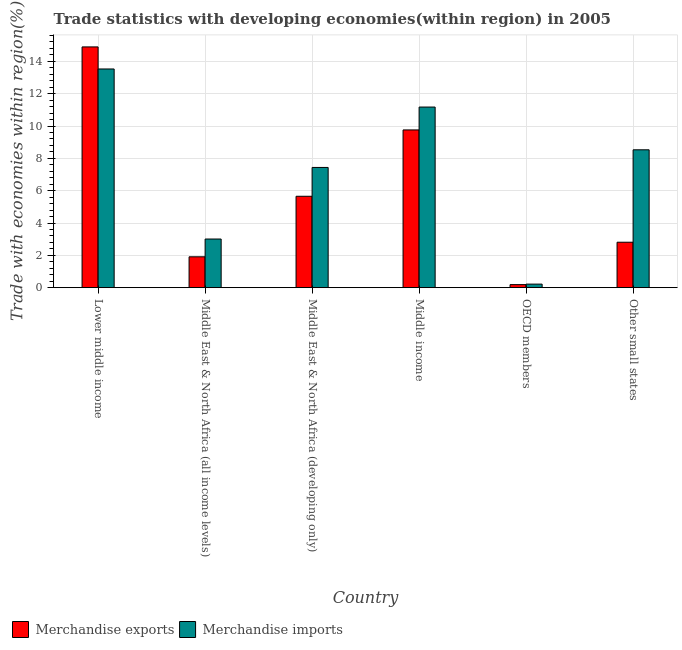How many bars are there on the 6th tick from the left?
Your answer should be compact. 2. How many bars are there on the 2nd tick from the right?
Ensure brevity in your answer.  2. What is the label of the 2nd group of bars from the left?
Make the answer very short. Middle East & North Africa (all income levels). In how many cases, is the number of bars for a given country not equal to the number of legend labels?
Offer a terse response. 0. What is the merchandise exports in Other small states?
Your answer should be compact. 2.81. Across all countries, what is the maximum merchandise exports?
Offer a terse response. 14.89. Across all countries, what is the minimum merchandise exports?
Provide a succinct answer. 0.19. In which country was the merchandise exports maximum?
Keep it short and to the point. Lower middle income. What is the total merchandise exports in the graph?
Keep it short and to the point. 35.21. What is the difference between the merchandise exports in Middle East & North Africa (developing only) and that in Other small states?
Ensure brevity in your answer.  2.84. What is the difference between the merchandise imports in OECD members and the merchandise exports in Middle income?
Your answer should be compact. -9.54. What is the average merchandise imports per country?
Ensure brevity in your answer.  7.32. What is the difference between the merchandise imports and merchandise exports in OECD members?
Give a very brief answer. 0.03. In how many countries, is the merchandise imports greater than 4.4 %?
Provide a succinct answer. 4. What is the ratio of the merchandise exports in Middle East & North Africa (developing only) to that in Middle income?
Offer a terse response. 0.58. What is the difference between the highest and the second highest merchandise imports?
Give a very brief answer. 2.36. What is the difference between the highest and the lowest merchandise exports?
Make the answer very short. 14.71. In how many countries, is the merchandise exports greater than the average merchandise exports taken over all countries?
Offer a terse response. 2. Is the sum of the merchandise imports in Middle income and Other small states greater than the maximum merchandise exports across all countries?
Ensure brevity in your answer.  Yes. What does the 2nd bar from the left in Other small states represents?
Your response must be concise. Merchandise imports. What does the 2nd bar from the right in Middle income represents?
Provide a succinct answer. Merchandise exports. How many bars are there?
Make the answer very short. 12. Does the graph contain any zero values?
Your response must be concise. No. How many legend labels are there?
Ensure brevity in your answer.  2. How are the legend labels stacked?
Your answer should be very brief. Horizontal. What is the title of the graph?
Provide a short and direct response. Trade statistics with developing economies(within region) in 2005. Does "ODA received" appear as one of the legend labels in the graph?
Offer a very short reply. No. What is the label or title of the Y-axis?
Keep it short and to the point. Trade with economies within region(%). What is the Trade with economies within region(%) in Merchandise exports in Lower middle income?
Your response must be concise. 14.89. What is the Trade with economies within region(%) of Merchandise imports in Lower middle income?
Give a very brief answer. 13.53. What is the Trade with economies within region(%) of Merchandise exports in Middle East & North Africa (all income levels)?
Offer a terse response. 1.91. What is the Trade with economies within region(%) of Merchandise imports in Middle East & North Africa (all income levels)?
Your answer should be compact. 3.01. What is the Trade with economies within region(%) of Merchandise exports in Middle East & North Africa (developing only)?
Provide a short and direct response. 5.65. What is the Trade with economies within region(%) in Merchandise imports in Middle East & North Africa (developing only)?
Provide a succinct answer. 7.44. What is the Trade with economies within region(%) of Merchandise exports in Middle income?
Make the answer very short. 9.76. What is the Trade with economies within region(%) in Merchandise imports in Middle income?
Your answer should be compact. 11.17. What is the Trade with economies within region(%) in Merchandise exports in OECD members?
Keep it short and to the point. 0.19. What is the Trade with economies within region(%) of Merchandise imports in OECD members?
Your answer should be very brief. 0.22. What is the Trade with economies within region(%) of Merchandise exports in Other small states?
Your answer should be compact. 2.81. What is the Trade with economies within region(%) of Merchandise imports in Other small states?
Your response must be concise. 8.53. Across all countries, what is the maximum Trade with economies within region(%) in Merchandise exports?
Make the answer very short. 14.89. Across all countries, what is the maximum Trade with economies within region(%) in Merchandise imports?
Give a very brief answer. 13.53. Across all countries, what is the minimum Trade with economies within region(%) of Merchandise exports?
Provide a short and direct response. 0.19. Across all countries, what is the minimum Trade with economies within region(%) of Merchandise imports?
Provide a short and direct response. 0.22. What is the total Trade with economies within region(%) of Merchandise exports in the graph?
Ensure brevity in your answer.  35.21. What is the total Trade with economies within region(%) in Merchandise imports in the graph?
Offer a very short reply. 43.9. What is the difference between the Trade with economies within region(%) in Merchandise exports in Lower middle income and that in Middle East & North Africa (all income levels)?
Offer a very short reply. 12.99. What is the difference between the Trade with economies within region(%) of Merchandise imports in Lower middle income and that in Middle East & North Africa (all income levels)?
Offer a very short reply. 10.52. What is the difference between the Trade with economies within region(%) in Merchandise exports in Lower middle income and that in Middle East & North Africa (developing only)?
Make the answer very short. 9.24. What is the difference between the Trade with economies within region(%) of Merchandise imports in Lower middle income and that in Middle East & North Africa (developing only)?
Provide a succinct answer. 6.09. What is the difference between the Trade with economies within region(%) in Merchandise exports in Lower middle income and that in Middle income?
Give a very brief answer. 5.14. What is the difference between the Trade with economies within region(%) in Merchandise imports in Lower middle income and that in Middle income?
Make the answer very short. 2.36. What is the difference between the Trade with economies within region(%) of Merchandise exports in Lower middle income and that in OECD members?
Offer a terse response. 14.71. What is the difference between the Trade with economies within region(%) of Merchandise imports in Lower middle income and that in OECD members?
Ensure brevity in your answer.  13.31. What is the difference between the Trade with economies within region(%) of Merchandise exports in Lower middle income and that in Other small states?
Make the answer very short. 12.08. What is the difference between the Trade with economies within region(%) in Merchandise imports in Lower middle income and that in Other small states?
Provide a succinct answer. 5. What is the difference between the Trade with economies within region(%) of Merchandise exports in Middle East & North Africa (all income levels) and that in Middle East & North Africa (developing only)?
Provide a short and direct response. -3.75. What is the difference between the Trade with economies within region(%) of Merchandise imports in Middle East & North Africa (all income levels) and that in Middle East & North Africa (developing only)?
Your answer should be very brief. -4.43. What is the difference between the Trade with economies within region(%) of Merchandise exports in Middle East & North Africa (all income levels) and that in Middle income?
Make the answer very short. -7.85. What is the difference between the Trade with economies within region(%) of Merchandise imports in Middle East & North Africa (all income levels) and that in Middle income?
Offer a very short reply. -8.16. What is the difference between the Trade with economies within region(%) of Merchandise exports in Middle East & North Africa (all income levels) and that in OECD members?
Ensure brevity in your answer.  1.72. What is the difference between the Trade with economies within region(%) of Merchandise imports in Middle East & North Africa (all income levels) and that in OECD members?
Make the answer very short. 2.79. What is the difference between the Trade with economies within region(%) in Merchandise exports in Middle East & North Africa (all income levels) and that in Other small states?
Offer a terse response. -0.9. What is the difference between the Trade with economies within region(%) in Merchandise imports in Middle East & North Africa (all income levels) and that in Other small states?
Your answer should be compact. -5.52. What is the difference between the Trade with economies within region(%) in Merchandise exports in Middle East & North Africa (developing only) and that in Middle income?
Your answer should be very brief. -4.1. What is the difference between the Trade with economies within region(%) in Merchandise imports in Middle East & North Africa (developing only) and that in Middle income?
Offer a very short reply. -3.74. What is the difference between the Trade with economies within region(%) in Merchandise exports in Middle East & North Africa (developing only) and that in OECD members?
Your response must be concise. 5.47. What is the difference between the Trade with economies within region(%) of Merchandise imports in Middle East & North Africa (developing only) and that in OECD members?
Your response must be concise. 7.22. What is the difference between the Trade with economies within region(%) of Merchandise exports in Middle East & North Africa (developing only) and that in Other small states?
Your answer should be compact. 2.84. What is the difference between the Trade with economies within region(%) in Merchandise imports in Middle East & North Africa (developing only) and that in Other small states?
Make the answer very short. -1.09. What is the difference between the Trade with economies within region(%) of Merchandise exports in Middle income and that in OECD members?
Your answer should be very brief. 9.57. What is the difference between the Trade with economies within region(%) in Merchandise imports in Middle income and that in OECD members?
Your answer should be compact. 10.95. What is the difference between the Trade with economies within region(%) of Merchandise exports in Middle income and that in Other small states?
Your answer should be compact. 6.95. What is the difference between the Trade with economies within region(%) in Merchandise imports in Middle income and that in Other small states?
Ensure brevity in your answer.  2.64. What is the difference between the Trade with economies within region(%) of Merchandise exports in OECD members and that in Other small states?
Keep it short and to the point. -2.62. What is the difference between the Trade with economies within region(%) of Merchandise imports in OECD members and that in Other small states?
Provide a short and direct response. -8.31. What is the difference between the Trade with economies within region(%) in Merchandise exports in Lower middle income and the Trade with economies within region(%) in Merchandise imports in Middle East & North Africa (all income levels)?
Your answer should be compact. 11.88. What is the difference between the Trade with economies within region(%) of Merchandise exports in Lower middle income and the Trade with economies within region(%) of Merchandise imports in Middle East & North Africa (developing only)?
Your answer should be very brief. 7.46. What is the difference between the Trade with economies within region(%) in Merchandise exports in Lower middle income and the Trade with economies within region(%) in Merchandise imports in Middle income?
Offer a very short reply. 3.72. What is the difference between the Trade with economies within region(%) of Merchandise exports in Lower middle income and the Trade with economies within region(%) of Merchandise imports in OECD members?
Offer a terse response. 14.68. What is the difference between the Trade with economies within region(%) of Merchandise exports in Lower middle income and the Trade with economies within region(%) of Merchandise imports in Other small states?
Give a very brief answer. 6.37. What is the difference between the Trade with economies within region(%) of Merchandise exports in Middle East & North Africa (all income levels) and the Trade with economies within region(%) of Merchandise imports in Middle East & North Africa (developing only)?
Your answer should be compact. -5.53. What is the difference between the Trade with economies within region(%) in Merchandise exports in Middle East & North Africa (all income levels) and the Trade with economies within region(%) in Merchandise imports in Middle income?
Ensure brevity in your answer.  -9.26. What is the difference between the Trade with economies within region(%) of Merchandise exports in Middle East & North Africa (all income levels) and the Trade with economies within region(%) of Merchandise imports in OECD members?
Make the answer very short. 1.69. What is the difference between the Trade with economies within region(%) in Merchandise exports in Middle East & North Africa (all income levels) and the Trade with economies within region(%) in Merchandise imports in Other small states?
Your answer should be compact. -6.62. What is the difference between the Trade with economies within region(%) of Merchandise exports in Middle East & North Africa (developing only) and the Trade with economies within region(%) of Merchandise imports in Middle income?
Your answer should be compact. -5.52. What is the difference between the Trade with economies within region(%) of Merchandise exports in Middle East & North Africa (developing only) and the Trade with economies within region(%) of Merchandise imports in OECD members?
Provide a succinct answer. 5.43. What is the difference between the Trade with economies within region(%) of Merchandise exports in Middle East & North Africa (developing only) and the Trade with economies within region(%) of Merchandise imports in Other small states?
Give a very brief answer. -2.87. What is the difference between the Trade with economies within region(%) in Merchandise exports in Middle income and the Trade with economies within region(%) in Merchandise imports in OECD members?
Ensure brevity in your answer.  9.54. What is the difference between the Trade with economies within region(%) of Merchandise exports in Middle income and the Trade with economies within region(%) of Merchandise imports in Other small states?
Make the answer very short. 1.23. What is the difference between the Trade with economies within region(%) of Merchandise exports in OECD members and the Trade with economies within region(%) of Merchandise imports in Other small states?
Offer a terse response. -8.34. What is the average Trade with economies within region(%) of Merchandise exports per country?
Provide a succinct answer. 5.87. What is the average Trade with economies within region(%) in Merchandise imports per country?
Provide a succinct answer. 7.32. What is the difference between the Trade with economies within region(%) in Merchandise exports and Trade with economies within region(%) in Merchandise imports in Lower middle income?
Your answer should be compact. 1.37. What is the difference between the Trade with economies within region(%) of Merchandise exports and Trade with economies within region(%) of Merchandise imports in Middle East & North Africa (all income levels)?
Give a very brief answer. -1.1. What is the difference between the Trade with economies within region(%) of Merchandise exports and Trade with economies within region(%) of Merchandise imports in Middle East & North Africa (developing only)?
Offer a very short reply. -1.78. What is the difference between the Trade with economies within region(%) of Merchandise exports and Trade with economies within region(%) of Merchandise imports in Middle income?
Provide a succinct answer. -1.41. What is the difference between the Trade with economies within region(%) in Merchandise exports and Trade with economies within region(%) in Merchandise imports in OECD members?
Your answer should be compact. -0.03. What is the difference between the Trade with economies within region(%) in Merchandise exports and Trade with economies within region(%) in Merchandise imports in Other small states?
Provide a short and direct response. -5.72. What is the ratio of the Trade with economies within region(%) in Merchandise exports in Lower middle income to that in Middle East & North Africa (all income levels)?
Your answer should be very brief. 7.8. What is the ratio of the Trade with economies within region(%) in Merchandise imports in Lower middle income to that in Middle East & North Africa (all income levels)?
Provide a short and direct response. 4.5. What is the ratio of the Trade with economies within region(%) of Merchandise exports in Lower middle income to that in Middle East & North Africa (developing only)?
Ensure brevity in your answer.  2.63. What is the ratio of the Trade with economies within region(%) in Merchandise imports in Lower middle income to that in Middle East & North Africa (developing only)?
Make the answer very short. 1.82. What is the ratio of the Trade with economies within region(%) of Merchandise exports in Lower middle income to that in Middle income?
Give a very brief answer. 1.53. What is the ratio of the Trade with economies within region(%) in Merchandise imports in Lower middle income to that in Middle income?
Your answer should be compact. 1.21. What is the ratio of the Trade with economies within region(%) in Merchandise exports in Lower middle income to that in OECD members?
Provide a short and direct response. 79.11. What is the ratio of the Trade with economies within region(%) in Merchandise imports in Lower middle income to that in OECD members?
Ensure brevity in your answer.  61.79. What is the ratio of the Trade with economies within region(%) of Merchandise exports in Lower middle income to that in Other small states?
Keep it short and to the point. 5.3. What is the ratio of the Trade with economies within region(%) of Merchandise imports in Lower middle income to that in Other small states?
Provide a succinct answer. 1.59. What is the ratio of the Trade with economies within region(%) in Merchandise exports in Middle East & North Africa (all income levels) to that in Middle East & North Africa (developing only)?
Make the answer very short. 0.34. What is the ratio of the Trade with economies within region(%) in Merchandise imports in Middle East & North Africa (all income levels) to that in Middle East & North Africa (developing only)?
Your answer should be very brief. 0.4. What is the ratio of the Trade with economies within region(%) in Merchandise exports in Middle East & North Africa (all income levels) to that in Middle income?
Keep it short and to the point. 0.2. What is the ratio of the Trade with economies within region(%) of Merchandise imports in Middle East & North Africa (all income levels) to that in Middle income?
Ensure brevity in your answer.  0.27. What is the ratio of the Trade with economies within region(%) in Merchandise exports in Middle East & North Africa (all income levels) to that in OECD members?
Make the answer very short. 10.14. What is the ratio of the Trade with economies within region(%) of Merchandise imports in Middle East & North Africa (all income levels) to that in OECD members?
Give a very brief answer. 13.74. What is the ratio of the Trade with economies within region(%) in Merchandise exports in Middle East & North Africa (all income levels) to that in Other small states?
Offer a very short reply. 0.68. What is the ratio of the Trade with economies within region(%) in Merchandise imports in Middle East & North Africa (all income levels) to that in Other small states?
Provide a succinct answer. 0.35. What is the ratio of the Trade with economies within region(%) of Merchandise exports in Middle East & North Africa (developing only) to that in Middle income?
Give a very brief answer. 0.58. What is the ratio of the Trade with economies within region(%) in Merchandise imports in Middle East & North Africa (developing only) to that in Middle income?
Provide a short and direct response. 0.67. What is the ratio of the Trade with economies within region(%) in Merchandise exports in Middle East & North Africa (developing only) to that in OECD members?
Offer a terse response. 30.03. What is the ratio of the Trade with economies within region(%) of Merchandise imports in Middle East & North Africa (developing only) to that in OECD members?
Provide a short and direct response. 33.97. What is the ratio of the Trade with economies within region(%) of Merchandise exports in Middle East & North Africa (developing only) to that in Other small states?
Provide a short and direct response. 2.01. What is the ratio of the Trade with economies within region(%) in Merchandise imports in Middle East & North Africa (developing only) to that in Other small states?
Give a very brief answer. 0.87. What is the ratio of the Trade with economies within region(%) of Merchandise exports in Middle income to that in OECD members?
Keep it short and to the point. 51.84. What is the ratio of the Trade with economies within region(%) of Merchandise imports in Middle income to that in OECD members?
Your answer should be compact. 51.03. What is the ratio of the Trade with economies within region(%) of Merchandise exports in Middle income to that in Other small states?
Offer a very short reply. 3.47. What is the ratio of the Trade with economies within region(%) of Merchandise imports in Middle income to that in Other small states?
Ensure brevity in your answer.  1.31. What is the ratio of the Trade with economies within region(%) in Merchandise exports in OECD members to that in Other small states?
Offer a very short reply. 0.07. What is the ratio of the Trade with economies within region(%) in Merchandise imports in OECD members to that in Other small states?
Offer a very short reply. 0.03. What is the difference between the highest and the second highest Trade with economies within region(%) of Merchandise exports?
Your answer should be very brief. 5.14. What is the difference between the highest and the second highest Trade with economies within region(%) of Merchandise imports?
Ensure brevity in your answer.  2.36. What is the difference between the highest and the lowest Trade with economies within region(%) of Merchandise exports?
Ensure brevity in your answer.  14.71. What is the difference between the highest and the lowest Trade with economies within region(%) in Merchandise imports?
Your answer should be compact. 13.31. 